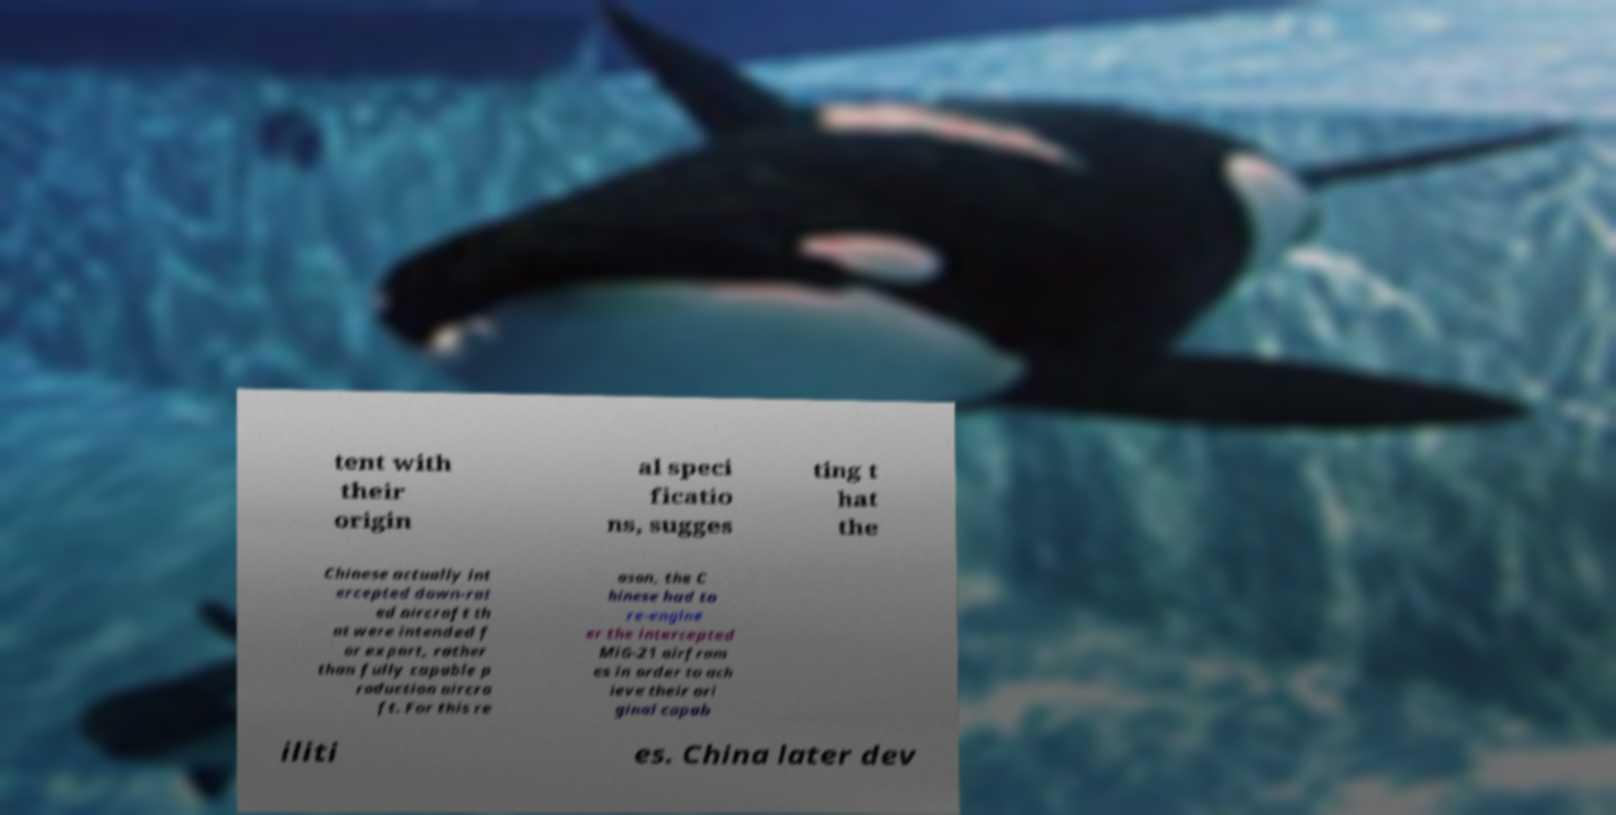For documentation purposes, I need the text within this image transcribed. Could you provide that? tent with their origin al speci ficatio ns, sugges ting t hat the Chinese actually int ercepted down-rat ed aircraft th at were intended f or export, rather than fully capable p roduction aircra ft. For this re ason, the C hinese had to re-engine er the intercepted MiG-21 airfram es in order to ach ieve their ori ginal capab iliti es. China later dev 